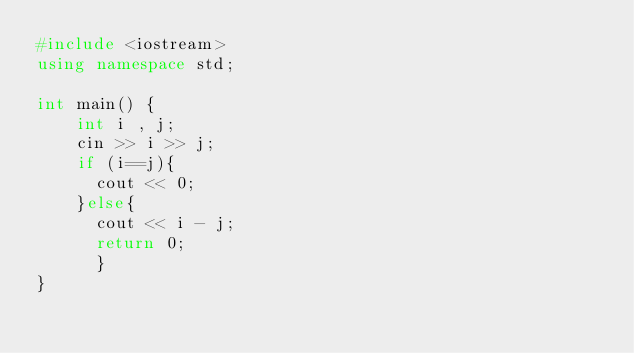Convert code to text. <code><loc_0><loc_0><loc_500><loc_500><_C++_>#include <iostream>
using namespace std;

int main() {
	int i , j;
    cin >> i >> j;
  	if (i==j){
      cout << 0;
    }else{  
      cout << i - j;
	  return 0;
      }
}</code> 